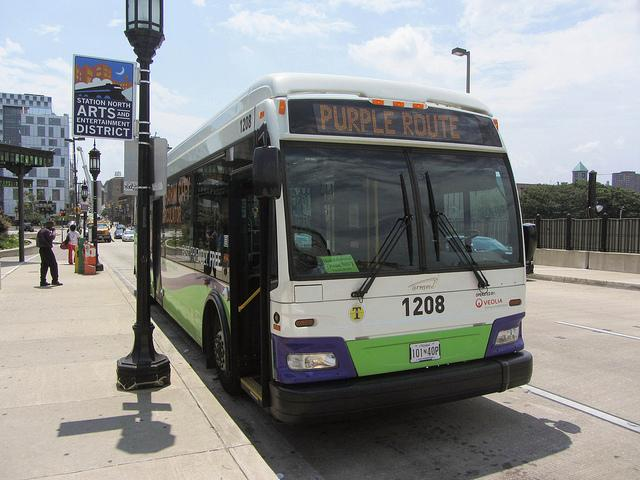What is the bus doing near the sidewalk? stopping 